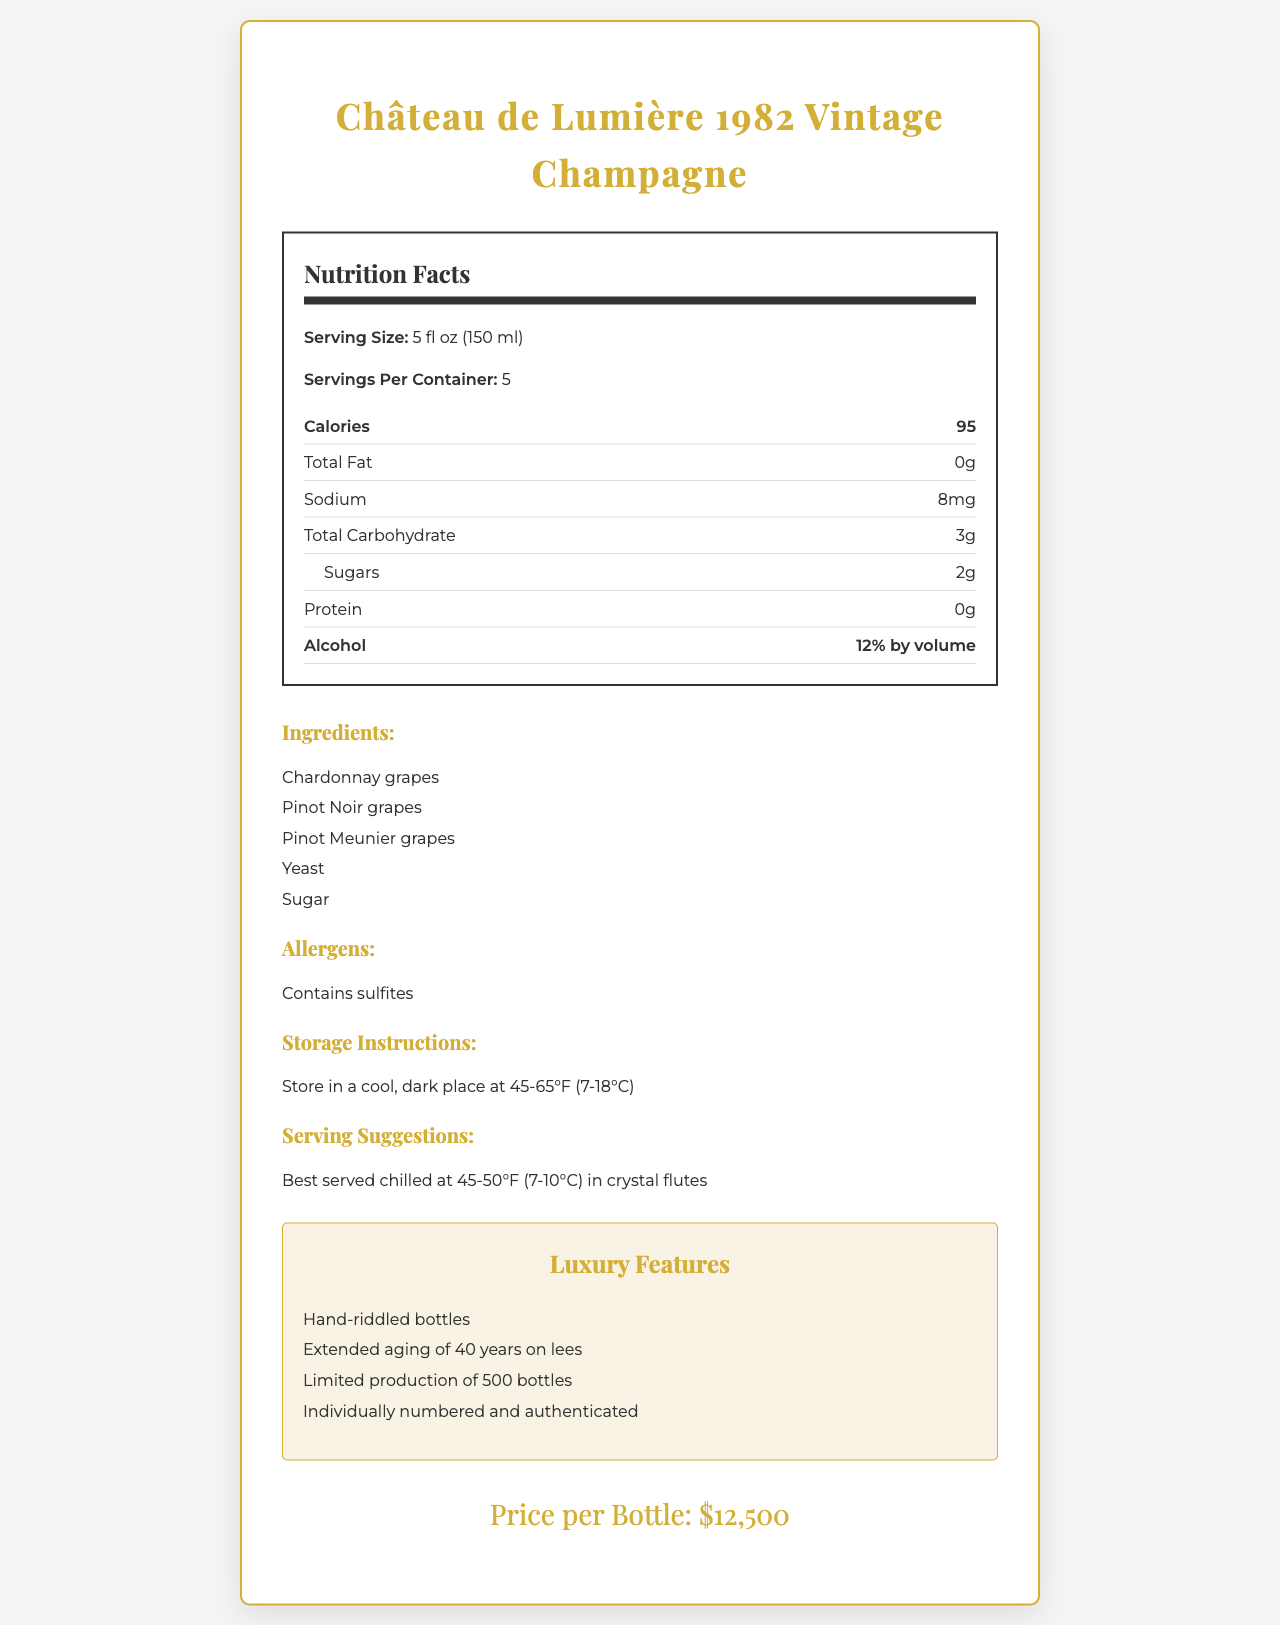what is the serving size of the champagne? The document lists the serving size directly under the "Nutrition Facts" section.
Answer: 5 fl oz (150 ml) how many calories are there per serving? This information is found in the "Nutrition Facts" section labeled "Calories".
Answer: 95 what are the ingredients of Château de Lumière 1982 Vintage Champagne? The "Ingredients" section lists these components.
Answer: Chardonnay grapes, Pinot Noir grapes, Pinot Meunier grapes, Yeast, Sugar how much protein does this champagne contain? The "Nutrition Facts" section states the amount of protein.
Answer: 0g what is the alcohol content by volume? The "Nutrition Facts" section specifies the alcohol content.
Answer: 12% what allergens does this champagne contain? The allergens are mentioned under the "Allergens" section.
Answer: Contains sulfites what are the suggested foods to pair with this champagne? A. Sushi, Pizza, Burger B. Beluga caviar, Fresh oysters, Lobster thermidor, Foie gras terrine C. Spaghetti, Garlic bread, Caesar salad The "Pairings" section lists suggested foods that include Beluga caviar, Fresh oysters, Lobster thermidor, and Foie gras terrine.
Answer: B how should Château de Lumière 1982 Vintage Champagne be stored? A. In a warm, sunny place B. In the refrigerator C. In a cool, dark place The "Storage Instructions" specify storing in a cool, dark place at 45-65°F (7-18°C).
Answer: C is this champagne suitable for someone who is allergic to sulfites? The "Allergens" section clearly states, "Contains sulfites".
Answer: No what are some of the luxury features of this champagne? These features are listed under the "Luxury Features" section.
Answer: Hand-riddled bottles, Extended aging of 40 years on lees, Limited production of 500 bottles, Individually numbered and authenticated describe the main aspects covered in the document The document provides a comprehensive overview of the champagne, highlighting its exclusive features, nutritional information, and appropriate pairings to enhance its luxurious image.
Answer: The document describes a luxury vintage champagne, Château de Lumière 1982, including its nutritional facts, ingredients, allergens, storage instructions, serving suggestions, luxury features, and pricing. It also includes tasting notes, food pairings, awards, sustainability information, and detailed packaging features. how much does a bottle of Château de Lumière 1982 Vintage Champagne cost? The price per bottle is prominently displayed at the bottom of the document.
Answer: $12,500 what is the sustainability information related to this champagne? This information is listed under the "Sustainability Info" section.
Answer: Grapes sourced from sustainable vineyards in Champagne, France which grapes are used in this champagne? The "Ingredients" section clarifies the types of grapes used.
Answer: Chardonnay grapes, Pinot Noir grapes, Pinot Meunier grapes what are the tasting notes associated with this champagne? The "Tasting Notes" section lists these sensory notes.
Answer: Delicate honey aroma, Subtle vanilla undertones, Hints of toasted brioche, Lingering notes of ripe apricot when was the Grand Gold Medal awarded to this champagne? The "Awards" section indicates that the Grand Gold Medal was awarded at the Champagne Masters in 2022.
Answer: 2022 what is the total fat content per serving? The "Nutrition Facts" section clearly indicates that the total fat content is 0 grams per serving.
Answer: 0g where was Château de Lumière 1982 won Best in Show? The "Awards" section mentions this accolade.
Answer: Decanter World Wine Awards in 2021 how long has Château de Lumière 1982 been aged on lees? This is detailed under the "Luxury Features" section.
Answer: 40 years what specific storage temperature is recommended for serving this champagne chilled? This specific serving suggestion is mentioned under "Serving Suggestions".
Answer: 45-50°F (7-10°C) how many calories are there in the entire bottle? There are 5 servings per container, each with 95 calories. 5 servings x 95 calories = 475 calories.
Answer: 475 calories what types of glasses are recommended for serving this champagne? The recommended glassware is mentioned under "Serving Suggestions".
Answer: Crystal flutes which of the following is not an ingredient used in Château de Lumière 1982? A. Chardonnay grapes B. Pinot Meunier grapes C. Cabernet Sauvignon grapes The "Ingredients" section lists Chardonnay, Pinot Noir, and Pinot Meunier grapes, but not Cabernet Sauvignon.
Answer: C what year is Château de Lumière 1982 Vintage Champagne from? The product name, "Château de Lumière 1982 Vintage Champagne," indicates the year.
Answer: 1982 how many bottles of Château de Lumière 1982 Vintage Champagne are produced? The production is limited to 500 bottles, as noted under "Luxury Features".
Answer: 500 what type of award did this champagne receive in 2022? The document mentions it received the Grand Gold Medal at the Champagne Masters in 2022.
Answer: Grand Gold Medal is there any information about how many years the champagne was aged? The document specifies that the champagne was aged for 40 years on lees under "Luxury Features".
Answer: Yes what does the packaging of Château de Lumière 1982 include? This is described under the "Packaging Details" section.
Answer: Baccarat crystal bottle, 24-karat gold leaf label, Silk-lined wooden presentation box are sulfites listed as an allergen in this champagne? The document under the "Allergens" section states "Contains sulfites".
Answer: Yes what is the primary flavor profile described in the tasting notes? The tasting notes collectively describe the primary flavor profiles.
Answer: Delicate honey aroma, Subtle vanilla undertones, Hints of toasted brioche, Lingering notes of ripe apricot what is the sugar content per serving? The "Nutrition Facts" section lists the sugar content per serving.
Answer: 2g what is the sodium content in a serving of Château de Lumière 1982? This detail is mentioned in the "Nutrition Facts" section under sodium.
Answer: 8mg how is the bottle of Château de Lumière 1982 authenticated? This luxury feature is noted under "Luxury Features".
Answer: Individually numbered and authenticated what are the total carbohydrates per serving? The total carbohydrate content is listed under the "Nutrition Facts" section.
Answer: 3g which ingredients does not the champagne contain? The document does not provide information about all potential ingredients not in the champagne.
Answer: I don't know 